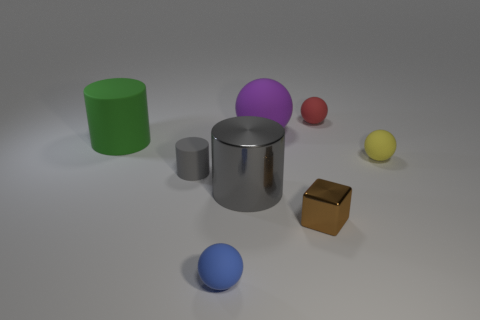Subtract all yellow spheres. How many spheres are left? 3 Subtract all cyan spheres. Subtract all yellow cylinders. How many spheres are left? 4 Add 2 yellow things. How many objects exist? 10 Subtract all cylinders. How many objects are left? 5 Subtract 1 purple balls. How many objects are left? 7 Subtract all small spheres. Subtract all large purple objects. How many objects are left? 4 Add 3 big purple matte balls. How many big purple matte balls are left? 4 Add 2 small yellow rubber spheres. How many small yellow rubber spheres exist? 3 